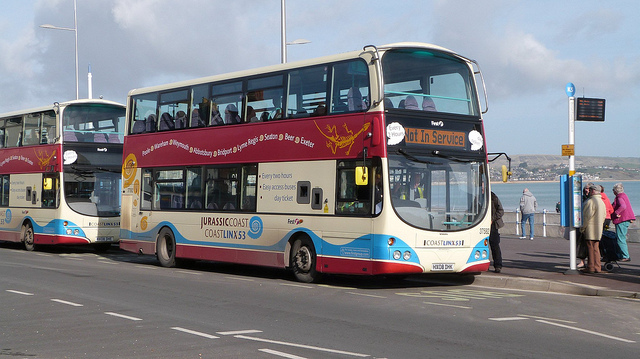Extract all visible text content from this image. JURASSIC COASTLINX53 Not In Service 